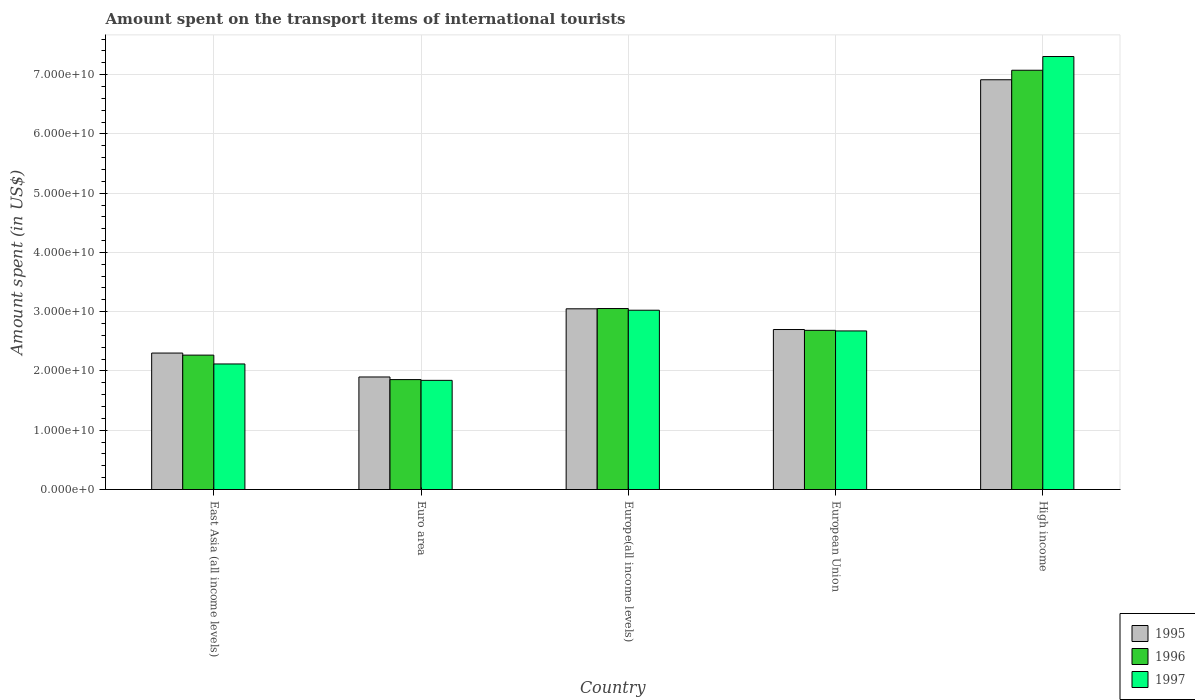How many different coloured bars are there?
Your answer should be very brief. 3. How many groups of bars are there?
Offer a very short reply. 5. Are the number of bars on each tick of the X-axis equal?
Make the answer very short. Yes. What is the label of the 4th group of bars from the left?
Ensure brevity in your answer.  European Union. What is the amount spent on the transport items of international tourists in 1995 in High income?
Offer a very short reply. 6.91e+1. Across all countries, what is the maximum amount spent on the transport items of international tourists in 1996?
Provide a succinct answer. 7.07e+1. Across all countries, what is the minimum amount spent on the transport items of international tourists in 1997?
Ensure brevity in your answer.  1.84e+1. In which country was the amount spent on the transport items of international tourists in 1995 maximum?
Offer a terse response. High income. In which country was the amount spent on the transport items of international tourists in 1997 minimum?
Give a very brief answer. Euro area. What is the total amount spent on the transport items of international tourists in 1996 in the graph?
Ensure brevity in your answer.  1.69e+11. What is the difference between the amount spent on the transport items of international tourists in 1995 in East Asia (all income levels) and that in European Union?
Keep it short and to the point. -3.97e+09. What is the difference between the amount spent on the transport items of international tourists in 1996 in Euro area and the amount spent on the transport items of international tourists in 1995 in High income?
Provide a succinct answer. -5.06e+1. What is the average amount spent on the transport items of international tourists in 1997 per country?
Give a very brief answer. 3.39e+1. What is the difference between the amount spent on the transport items of international tourists of/in 1995 and amount spent on the transport items of international tourists of/in 1996 in European Union?
Provide a short and direct response. 1.37e+08. What is the ratio of the amount spent on the transport items of international tourists in 1997 in East Asia (all income levels) to that in Europe(all income levels)?
Your response must be concise. 0.7. Is the amount spent on the transport items of international tourists in 1997 in East Asia (all income levels) less than that in Euro area?
Your answer should be very brief. No. Is the difference between the amount spent on the transport items of international tourists in 1995 in Europe(all income levels) and High income greater than the difference between the amount spent on the transport items of international tourists in 1996 in Europe(all income levels) and High income?
Offer a very short reply. Yes. What is the difference between the highest and the second highest amount spent on the transport items of international tourists in 1995?
Offer a terse response. -3.50e+09. What is the difference between the highest and the lowest amount spent on the transport items of international tourists in 1996?
Give a very brief answer. 5.22e+1. In how many countries, is the amount spent on the transport items of international tourists in 1995 greater than the average amount spent on the transport items of international tourists in 1995 taken over all countries?
Your response must be concise. 1. Is the sum of the amount spent on the transport items of international tourists in 1997 in Euro area and Europe(all income levels) greater than the maximum amount spent on the transport items of international tourists in 1996 across all countries?
Provide a succinct answer. No. Is it the case that in every country, the sum of the amount spent on the transport items of international tourists in 1995 and amount spent on the transport items of international tourists in 1996 is greater than the amount spent on the transport items of international tourists in 1997?
Offer a very short reply. Yes. How many bars are there?
Provide a succinct answer. 15. Are all the bars in the graph horizontal?
Keep it short and to the point. No. Are the values on the major ticks of Y-axis written in scientific E-notation?
Your response must be concise. Yes. Does the graph contain any zero values?
Provide a succinct answer. No. Does the graph contain grids?
Offer a terse response. Yes. How many legend labels are there?
Ensure brevity in your answer.  3. How are the legend labels stacked?
Your answer should be very brief. Vertical. What is the title of the graph?
Give a very brief answer. Amount spent on the transport items of international tourists. Does "1963" appear as one of the legend labels in the graph?
Your answer should be very brief. No. What is the label or title of the Y-axis?
Provide a succinct answer. Amount spent (in US$). What is the Amount spent (in US$) of 1995 in East Asia (all income levels)?
Your answer should be very brief. 2.30e+1. What is the Amount spent (in US$) of 1996 in East Asia (all income levels)?
Ensure brevity in your answer.  2.27e+1. What is the Amount spent (in US$) in 1997 in East Asia (all income levels)?
Keep it short and to the point. 2.12e+1. What is the Amount spent (in US$) of 1995 in Euro area?
Provide a succinct answer. 1.90e+1. What is the Amount spent (in US$) in 1996 in Euro area?
Keep it short and to the point. 1.85e+1. What is the Amount spent (in US$) of 1997 in Euro area?
Make the answer very short. 1.84e+1. What is the Amount spent (in US$) of 1995 in Europe(all income levels)?
Give a very brief answer. 3.05e+1. What is the Amount spent (in US$) in 1996 in Europe(all income levels)?
Give a very brief answer. 3.05e+1. What is the Amount spent (in US$) in 1997 in Europe(all income levels)?
Your answer should be compact. 3.03e+1. What is the Amount spent (in US$) of 1995 in European Union?
Your answer should be very brief. 2.70e+1. What is the Amount spent (in US$) in 1996 in European Union?
Your answer should be very brief. 2.69e+1. What is the Amount spent (in US$) of 1997 in European Union?
Provide a succinct answer. 2.68e+1. What is the Amount spent (in US$) in 1995 in High income?
Provide a succinct answer. 6.91e+1. What is the Amount spent (in US$) of 1996 in High income?
Offer a terse response. 7.07e+1. What is the Amount spent (in US$) in 1997 in High income?
Your answer should be compact. 7.31e+1. Across all countries, what is the maximum Amount spent (in US$) in 1995?
Provide a short and direct response. 6.91e+1. Across all countries, what is the maximum Amount spent (in US$) in 1996?
Offer a terse response. 7.07e+1. Across all countries, what is the maximum Amount spent (in US$) of 1997?
Your answer should be very brief. 7.31e+1. Across all countries, what is the minimum Amount spent (in US$) of 1995?
Your answer should be very brief. 1.90e+1. Across all countries, what is the minimum Amount spent (in US$) in 1996?
Provide a short and direct response. 1.85e+1. Across all countries, what is the minimum Amount spent (in US$) in 1997?
Offer a terse response. 1.84e+1. What is the total Amount spent (in US$) of 1995 in the graph?
Offer a very short reply. 1.69e+11. What is the total Amount spent (in US$) of 1996 in the graph?
Provide a succinct answer. 1.69e+11. What is the total Amount spent (in US$) of 1997 in the graph?
Your answer should be very brief. 1.70e+11. What is the difference between the Amount spent (in US$) in 1995 in East Asia (all income levels) and that in Euro area?
Your answer should be very brief. 4.04e+09. What is the difference between the Amount spent (in US$) in 1996 in East Asia (all income levels) and that in Euro area?
Provide a succinct answer. 4.13e+09. What is the difference between the Amount spent (in US$) of 1997 in East Asia (all income levels) and that in Euro area?
Your response must be concise. 2.76e+09. What is the difference between the Amount spent (in US$) of 1995 in East Asia (all income levels) and that in Europe(all income levels)?
Offer a very short reply. -7.47e+09. What is the difference between the Amount spent (in US$) in 1996 in East Asia (all income levels) and that in Europe(all income levels)?
Your response must be concise. -7.86e+09. What is the difference between the Amount spent (in US$) of 1997 in East Asia (all income levels) and that in Europe(all income levels)?
Offer a terse response. -9.07e+09. What is the difference between the Amount spent (in US$) in 1995 in East Asia (all income levels) and that in European Union?
Offer a very short reply. -3.97e+09. What is the difference between the Amount spent (in US$) of 1996 in East Asia (all income levels) and that in European Union?
Keep it short and to the point. -4.18e+09. What is the difference between the Amount spent (in US$) in 1997 in East Asia (all income levels) and that in European Union?
Provide a succinct answer. -5.57e+09. What is the difference between the Amount spent (in US$) of 1995 in East Asia (all income levels) and that in High income?
Your answer should be very brief. -4.61e+1. What is the difference between the Amount spent (in US$) of 1996 in East Asia (all income levels) and that in High income?
Keep it short and to the point. -4.81e+1. What is the difference between the Amount spent (in US$) of 1997 in East Asia (all income levels) and that in High income?
Provide a short and direct response. -5.19e+1. What is the difference between the Amount spent (in US$) of 1995 in Euro area and that in Europe(all income levels)?
Provide a short and direct response. -1.15e+1. What is the difference between the Amount spent (in US$) in 1996 in Euro area and that in Europe(all income levels)?
Ensure brevity in your answer.  -1.20e+1. What is the difference between the Amount spent (in US$) of 1997 in Euro area and that in Europe(all income levels)?
Offer a terse response. -1.18e+1. What is the difference between the Amount spent (in US$) in 1995 in Euro area and that in European Union?
Give a very brief answer. -8.01e+09. What is the difference between the Amount spent (in US$) of 1996 in Euro area and that in European Union?
Your answer should be compact. -8.31e+09. What is the difference between the Amount spent (in US$) in 1997 in Euro area and that in European Union?
Provide a short and direct response. -8.34e+09. What is the difference between the Amount spent (in US$) of 1995 in Euro area and that in High income?
Offer a terse response. -5.01e+1. What is the difference between the Amount spent (in US$) of 1996 in Euro area and that in High income?
Your answer should be compact. -5.22e+1. What is the difference between the Amount spent (in US$) in 1997 in Euro area and that in High income?
Ensure brevity in your answer.  -5.46e+1. What is the difference between the Amount spent (in US$) of 1995 in Europe(all income levels) and that in European Union?
Provide a succinct answer. 3.50e+09. What is the difference between the Amount spent (in US$) in 1996 in Europe(all income levels) and that in European Union?
Your answer should be compact. 3.68e+09. What is the difference between the Amount spent (in US$) of 1997 in Europe(all income levels) and that in European Union?
Your answer should be compact. 3.49e+09. What is the difference between the Amount spent (in US$) in 1995 in Europe(all income levels) and that in High income?
Ensure brevity in your answer.  -3.86e+1. What is the difference between the Amount spent (in US$) in 1996 in Europe(all income levels) and that in High income?
Your response must be concise. -4.02e+1. What is the difference between the Amount spent (in US$) of 1997 in Europe(all income levels) and that in High income?
Ensure brevity in your answer.  -4.28e+1. What is the difference between the Amount spent (in US$) in 1995 in European Union and that in High income?
Make the answer very short. -4.21e+1. What is the difference between the Amount spent (in US$) of 1996 in European Union and that in High income?
Keep it short and to the point. -4.39e+1. What is the difference between the Amount spent (in US$) in 1997 in European Union and that in High income?
Your response must be concise. -4.63e+1. What is the difference between the Amount spent (in US$) of 1995 in East Asia (all income levels) and the Amount spent (in US$) of 1996 in Euro area?
Give a very brief answer. 4.48e+09. What is the difference between the Amount spent (in US$) of 1995 in East Asia (all income levels) and the Amount spent (in US$) of 1997 in Euro area?
Your response must be concise. 4.61e+09. What is the difference between the Amount spent (in US$) in 1996 in East Asia (all income levels) and the Amount spent (in US$) in 1997 in Euro area?
Your response must be concise. 4.26e+09. What is the difference between the Amount spent (in US$) in 1995 in East Asia (all income levels) and the Amount spent (in US$) in 1996 in Europe(all income levels)?
Provide a short and direct response. -7.51e+09. What is the difference between the Amount spent (in US$) of 1995 in East Asia (all income levels) and the Amount spent (in US$) of 1997 in Europe(all income levels)?
Your response must be concise. -7.23e+09. What is the difference between the Amount spent (in US$) in 1996 in East Asia (all income levels) and the Amount spent (in US$) in 1997 in Europe(all income levels)?
Provide a short and direct response. -7.58e+09. What is the difference between the Amount spent (in US$) in 1995 in East Asia (all income levels) and the Amount spent (in US$) in 1996 in European Union?
Your answer should be compact. -3.83e+09. What is the difference between the Amount spent (in US$) in 1995 in East Asia (all income levels) and the Amount spent (in US$) in 1997 in European Union?
Your answer should be compact. -3.73e+09. What is the difference between the Amount spent (in US$) of 1996 in East Asia (all income levels) and the Amount spent (in US$) of 1997 in European Union?
Offer a very short reply. -4.08e+09. What is the difference between the Amount spent (in US$) in 1995 in East Asia (all income levels) and the Amount spent (in US$) in 1996 in High income?
Ensure brevity in your answer.  -4.77e+1. What is the difference between the Amount spent (in US$) in 1995 in East Asia (all income levels) and the Amount spent (in US$) in 1997 in High income?
Your response must be concise. -5.00e+1. What is the difference between the Amount spent (in US$) in 1996 in East Asia (all income levels) and the Amount spent (in US$) in 1997 in High income?
Keep it short and to the point. -5.04e+1. What is the difference between the Amount spent (in US$) of 1995 in Euro area and the Amount spent (in US$) of 1996 in Europe(all income levels)?
Your answer should be very brief. -1.15e+1. What is the difference between the Amount spent (in US$) in 1995 in Euro area and the Amount spent (in US$) in 1997 in Europe(all income levels)?
Your response must be concise. -1.13e+1. What is the difference between the Amount spent (in US$) of 1996 in Euro area and the Amount spent (in US$) of 1997 in Europe(all income levels)?
Keep it short and to the point. -1.17e+1. What is the difference between the Amount spent (in US$) of 1995 in Euro area and the Amount spent (in US$) of 1996 in European Union?
Provide a short and direct response. -7.87e+09. What is the difference between the Amount spent (in US$) in 1995 in Euro area and the Amount spent (in US$) in 1997 in European Union?
Your response must be concise. -7.77e+09. What is the difference between the Amount spent (in US$) of 1996 in Euro area and the Amount spent (in US$) of 1997 in European Union?
Provide a succinct answer. -8.21e+09. What is the difference between the Amount spent (in US$) of 1995 in Euro area and the Amount spent (in US$) of 1996 in High income?
Your answer should be very brief. -5.18e+1. What is the difference between the Amount spent (in US$) of 1995 in Euro area and the Amount spent (in US$) of 1997 in High income?
Give a very brief answer. -5.41e+1. What is the difference between the Amount spent (in US$) of 1996 in Euro area and the Amount spent (in US$) of 1997 in High income?
Keep it short and to the point. -5.45e+1. What is the difference between the Amount spent (in US$) in 1995 in Europe(all income levels) and the Amount spent (in US$) in 1996 in European Union?
Make the answer very short. 3.63e+09. What is the difference between the Amount spent (in US$) in 1995 in Europe(all income levels) and the Amount spent (in US$) in 1997 in European Union?
Your response must be concise. 3.73e+09. What is the difference between the Amount spent (in US$) of 1996 in Europe(all income levels) and the Amount spent (in US$) of 1997 in European Union?
Keep it short and to the point. 3.78e+09. What is the difference between the Amount spent (in US$) of 1995 in Europe(all income levels) and the Amount spent (in US$) of 1996 in High income?
Your response must be concise. -4.02e+1. What is the difference between the Amount spent (in US$) of 1995 in Europe(all income levels) and the Amount spent (in US$) of 1997 in High income?
Ensure brevity in your answer.  -4.26e+1. What is the difference between the Amount spent (in US$) of 1996 in Europe(all income levels) and the Amount spent (in US$) of 1997 in High income?
Your answer should be very brief. -4.25e+1. What is the difference between the Amount spent (in US$) in 1995 in European Union and the Amount spent (in US$) in 1996 in High income?
Give a very brief answer. -4.37e+1. What is the difference between the Amount spent (in US$) in 1995 in European Union and the Amount spent (in US$) in 1997 in High income?
Provide a succinct answer. -4.61e+1. What is the difference between the Amount spent (in US$) in 1996 in European Union and the Amount spent (in US$) in 1997 in High income?
Give a very brief answer. -4.62e+1. What is the average Amount spent (in US$) of 1995 per country?
Offer a very short reply. 3.37e+1. What is the average Amount spent (in US$) of 1996 per country?
Ensure brevity in your answer.  3.39e+1. What is the average Amount spent (in US$) of 1997 per country?
Offer a very short reply. 3.39e+1. What is the difference between the Amount spent (in US$) of 1995 and Amount spent (in US$) of 1996 in East Asia (all income levels)?
Keep it short and to the point. 3.50e+08. What is the difference between the Amount spent (in US$) of 1995 and Amount spent (in US$) of 1997 in East Asia (all income levels)?
Make the answer very short. 1.84e+09. What is the difference between the Amount spent (in US$) of 1996 and Amount spent (in US$) of 1997 in East Asia (all income levels)?
Your answer should be compact. 1.49e+09. What is the difference between the Amount spent (in US$) of 1995 and Amount spent (in US$) of 1996 in Euro area?
Offer a terse response. 4.42e+08. What is the difference between the Amount spent (in US$) of 1995 and Amount spent (in US$) of 1997 in Euro area?
Offer a very short reply. 5.69e+08. What is the difference between the Amount spent (in US$) of 1996 and Amount spent (in US$) of 1997 in Euro area?
Your response must be concise. 1.27e+08. What is the difference between the Amount spent (in US$) in 1995 and Amount spent (in US$) in 1996 in Europe(all income levels)?
Your answer should be compact. -4.44e+07. What is the difference between the Amount spent (in US$) in 1995 and Amount spent (in US$) in 1997 in Europe(all income levels)?
Your response must be concise. 2.41e+08. What is the difference between the Amount spent (in US$) of 1996 and Amount spent (in US$) of 1997 in Europe(all income levels)?
Your response must be concise. 2.85e+08. What is the difference between the Amount spent (in US$) of 1995 and Amount spent (in US$) of 1996 in European Union?
Your answer should be very brief. 1.37e+08. What is the difference between the Amount spent (in US$) of 1995 and Amount spent (in US$) of 1997 in European Union?
Make the answer very short. 2.35e+08. What is the difference between the Amount spent (in US$) in 1996 and Amount spent (in US$) in 1997 in European Union?
Make the answer very short. 9.81e+07. What is the difference between the Amount spent (in US$) of 1995 and Amount spent (in US$) of 1996 in High income?
Offer a very short reply. -1.61e+09. What is the difference between the Amount spent (in US$) of 1995 and Amount spent (in US$) of 1997 in High income?
Make the answer very short. -3.92e+09. What is the difference between the Amount spent (in US$) of 1996 and Amount spent (in US$) of 1997 in High income?
Ensure brevity in your answer.  -2.31e+09. What is the ratio of the Amount spent (in US$) of 1995 in East Asia (all income levels) to that in Euro area?
Provide a short and direct response. 1.21. What is the ratio of the Amount spent (in US$) in 1996 in East Asia (all income levels) to that in Euro area?
Your answer should be compact. 1.22. What is the ratio of the Amount spent (in US$) in 1997 in East Asia (all income levels) to that in Euro area?
Give a very brief answer. 1.15. What is the ratio of the Amount spent (in US$) in 1995 in East Asia (all income levels) to that in Europe(all income levels)?
Your answer should be very brief. 0.76. What is the ratio of the Amount spent (in US$) of 1996 in East Asia (all income levels) to that in Europe(all income levels)?
Offer a very short reply. 0.74. What is the ratio of the Amount spent (in US$) in 1997 in East Asia (all income levels) to that in Europe(all income levels)?
Ensure brevity in your answer.  0.7. What is the ratio of the Amount spent (in US$) of 1995 in East Asia (all income levels) to that in European Union?
Offer a terse response. 0.85. What is the ratio of the Amount spent (in US$) of 1996 in East Asia (all income levels) to that in European Union?
Make the answer very short. 0.84. What is the ratio of the Amount spent (in US$) in 1997 in East Asia (all income levels) to that in European Union?
Your answer should be compact. 0.79. What is the ratio of the Amount spent (in US$) of 1995 in East Asia (all income levels) to that in High income?
Your answer should be very brief. 0.33. What is the ratio of the Amount spent (in US$) of 1996 in East Asia (all income levels) to that in High income?
Keep it short and to the point. 0.32. What is the ratio of the Amount spent (in US$) of 1997 in East Asia (all income levels) to that in High income?
Offer a terse response. 0.29. What is the ratio of the Amount spent (in US$) of 1995 in Euro area to that in Europe(all income levels)?
Give a very brief answer. 0.62. What is the ratio of the Amount spent (in US$) of 1996 in Euro area to that in Europe(all income levels)?
Your response must be concise. 0.61. What is the ratio of the Amount spent (in US$) in 1997 in Euro area to that in Europe(all income levels)?
Give a very brief answer. 0.61. What is the ratio of the Amount spent (in US$) of 1995 in Euro area to that in European Union?
Offer a terse response. 0.7. What is the ratio of the Amount spent (in US$) of 1996 in Euro area to that in European Union?
Your response must be concise. 0.69. What is the ratio of the Amount spent (in US$) in 1997 in Euro area to that in European Union?
Make the answer very short. 0.69. What is the ratio of the Amount spent (in US$) of 1995 in Euro area to that in High income?
Your answer should be very brief. 0.27. What is the ratio of the Amount spent (in US$) in 1996 in Euro area to that in High income?
Provide a short and direct response. 0.26. What is the ratio of the Amount spent (in US$) in 1997 in Euro area to that in High income?
Your answer should be compact. 0.25. What is the ratio of the Amount spent (in US$) in 1995 in Europe(all income levels) to that in European Union?
Provide a short and direct response. 1.13. What is the ratio of the Amount spent (in US$) of 1996 in Europe(all income levels) to that in European Union?
Provide a short and direct response. 1.14. What is the ratio of the Amount spent (in US$) in 1997 in Europe(all income levels) to that in European Union?
Ensure brevity in your answer.  1.13. What is the ratio of the Amount spent (in US$) of 1995 in Europe(all income levels) to that in High income?
Your response must be concise. 0.44. What is the ratio of the Amount spent (in US$) in 1996 in Europe(all income levels) to that in High income?
Offer a terse response. 0.43. What is the ratio of the Amount spent (in US$) in 1997 in Europe(all income levels) to that in High income?
Your answer should be very brief. 0.41. What is the ratio of the Amount spent (in US$) of 1995 in European Union to that in High income?
Keep it short and to the point. 0.39. What is the ratio of the Amount spent (in US$) in 1996 in European Union to that in High income?
Give a very brief answer. 0.38. What is the ratio of the Amount spent (in US$) in 1997 in European Union to that in High income?
Offer a terse response. 0.37. What is the difference between the highest and the second highest Amount spent (in US$) in 1995?
Provide a short and direct response. 3.86e+1. What is the difference between the highest and the second highest Amount spent (in US$) of 1996?
Make the answer very short. 4.02e+1. What is the difference between the highest and the second highest Amount spent (in US$) in 1997?
Offer a terse response. 4.28e+1. What is the difference between the highest and the lowest Amount spent (in US$) of 1995?
Ensure brevity in your answer.  5.01e+1. What is the difference between the highest and the lowest Amount spent (in US$) in 1996?
Give a very brief answer. 5.22e+1. What is the difference between the highest and the lowest Amount spent (in US$) in 1997?
Your answer should be very brief. 5.46e+1. 